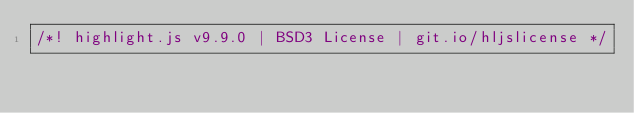Convert code to text. <code><loc_0><loc_0><loc_500><loc_500><_JavaScript_>/*! highlight.js v9.9.0 | BSD3 License | git.io/hljslicense */</code> 